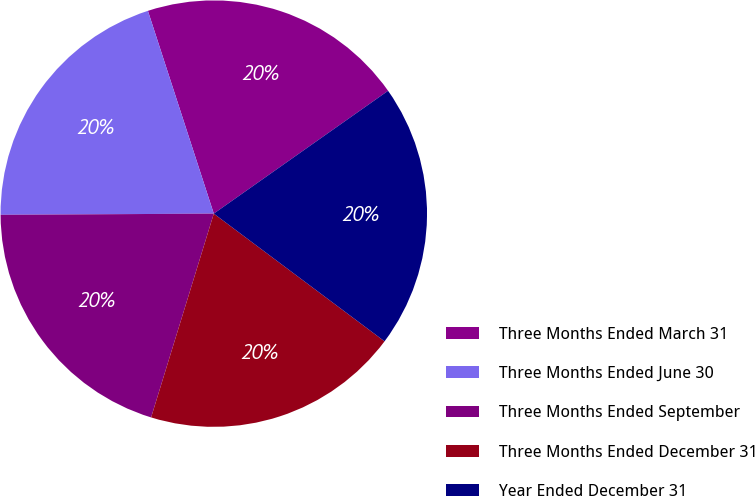Convert chart. <chart><loc_0><loc_0><loc_500><loc_500><pie_chart><fcel>Three Months Ended March 31<fcel>Three Months Ended June 30<fcel>Three Months Ended September<fcel>Three Months Ended December 31<fcel>Year Ended December 31<nl><fcel>20.23%<fcel>20.09%<fcel>20.16%<fcel>19.53%<fcel>19.99%<nl></chart> 